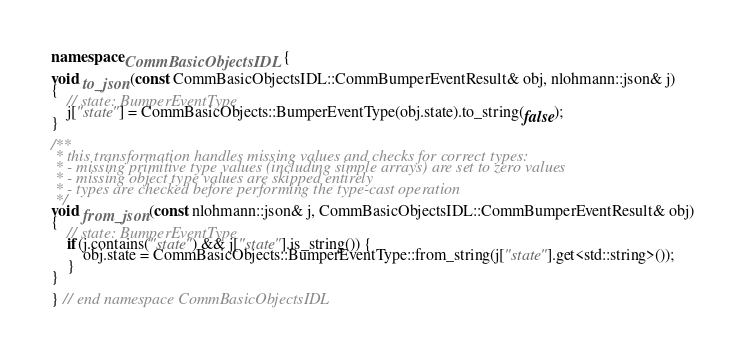<code> <loc_0><loc_0><loc_500><loc_500><_C++_>namespace CommBasicObjectsIDL {

void to_json(const CommBasicObjectsIDL::CommBumperEventResult& obj, nlohmann::json& j)
{
	// state: BumperEventType
	j["state"] = CommBasicObjects::BumperEventType(obj.state).to_string(false);
}

/**
 * this transformation handles missing values and checks for correct types:
 * - missing primitive type values (including simple arrays) are set to zero values
 * - missing object type values are skipped entirely
 * - types are checked before performing the type-cast operation
 */
void from_json(const nlohmann::json& j, CommBasicObjectsIDL::CommBumperEventResult& obj)
{
	// state: BumperEventType
	if(j.contains("state") && j["state"].is_string()) {
		obj.state = CommBasicObjects::BumperEventType::from_string(j["state"].get<std::string>());
	}
}

} // end namespace CommBasicObjectsIDL
</code> 